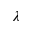<formula> <loc_0><loc_0><loc_500><loc_500>\lambda</formula> 